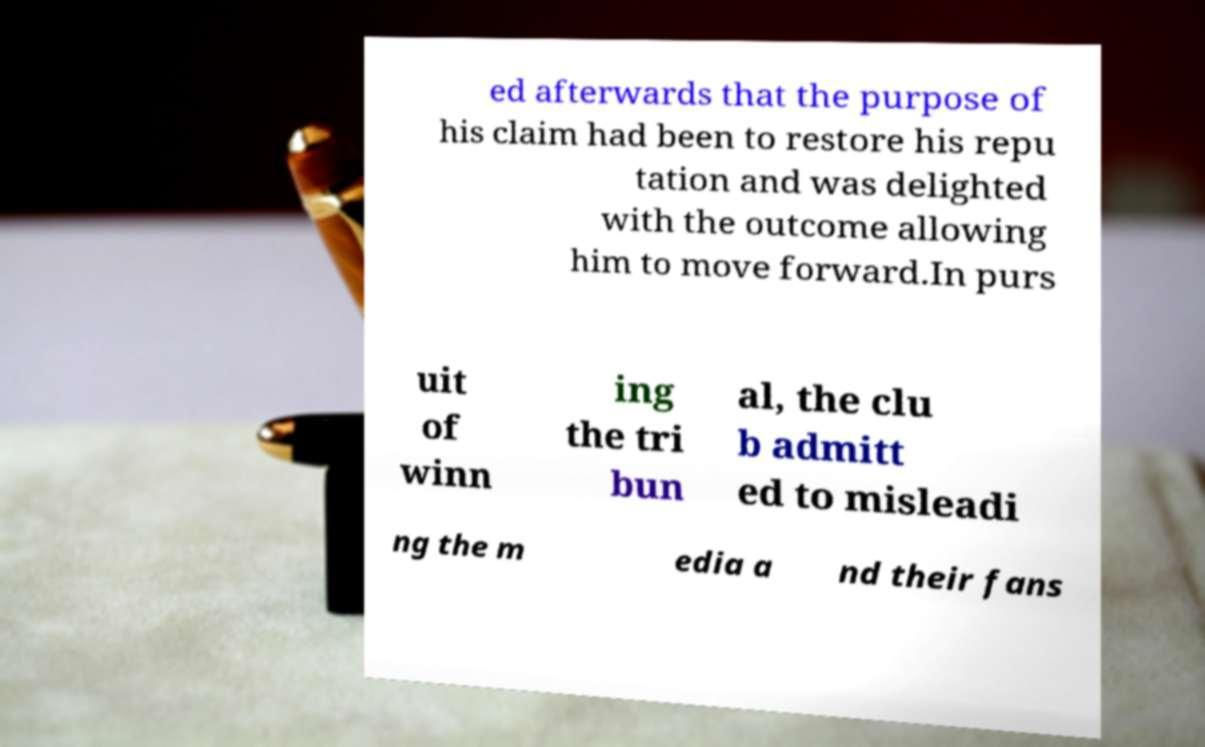For documentation purposes, I need the text within this image transcribed. Could you provide that? ed afterwards that the purpose of his claim had been to restore his repu tation and was delighted with the outcome allowing him to move forward.In purs uit of winn ing the tri bun al, the clu b admitt ed to misleadi ng the m edia a nd their fans 